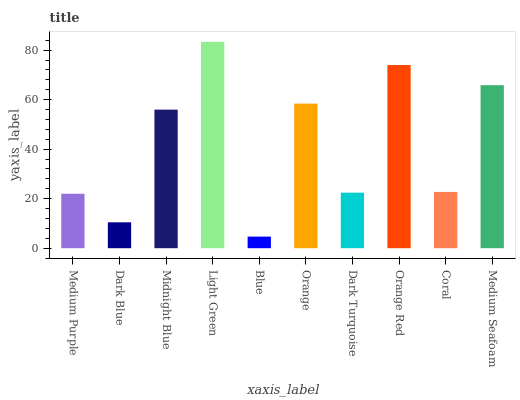Is Blue the minimum?
Answer yes or no. Yes. Is Light Green the maximum?
Answer yes or no. Yes. Is Dark Blue the minimum?
Answer yes or no. No. Is Dark Blue the maximum?
Answer yes or no. No. Is Medium Purple greater than Dark Blue?
Answer yes or no. Yes. Is Dark Blue less than Medium Purple?
Answer yes or no. Yes. Is Dark Blue greater than Medium Purple?
Answer yes or no. No. Is Medium Purple less than Dark Blue?
Answer yes or no. No. Is Midnight Blue the high median?
Answer yes or no. Yes. Is Coral the low median?
Answer yes or no. Yes. Is Orange Red the high median?
Answer yes or no. No. Is Orange the low median?
Answer yes or no. No. 